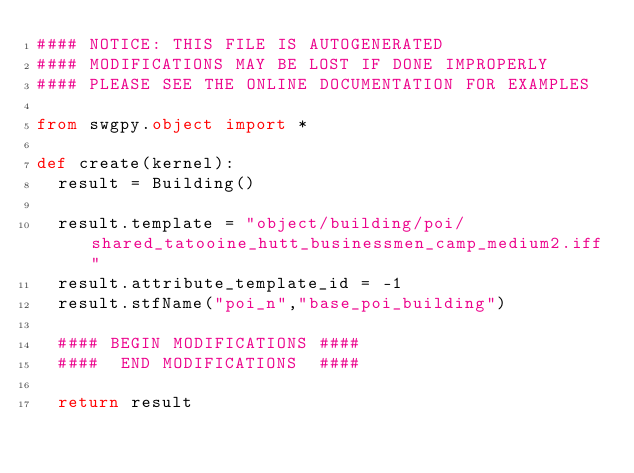Convert code to text. <code><loc_0><loc_0><loc_500><loc_500><_Python_>#### NOTICE: THIS FILE IS AUTOGENERATED
#### MODIFICATIONS MAY BE LOST IF DONE IMPROPERLY
#### PLEASE SEE THE ONLINE DOCUMENTATION FOR EXAMPLES

from swgpy.object import *	

def create(kernel):
	result = Building()

	result.template = "object/building/poi/shared_tatooine_hutt_businessmen_camp_medium2.iff"
	result.attribute_template_id = -1
	result.stfName("poi_n","base_poi_building")		
	
	#### BEGIN MODIFICATIONS ####
	####  END MODIFICATIONS  ####
	
	return result</code> 